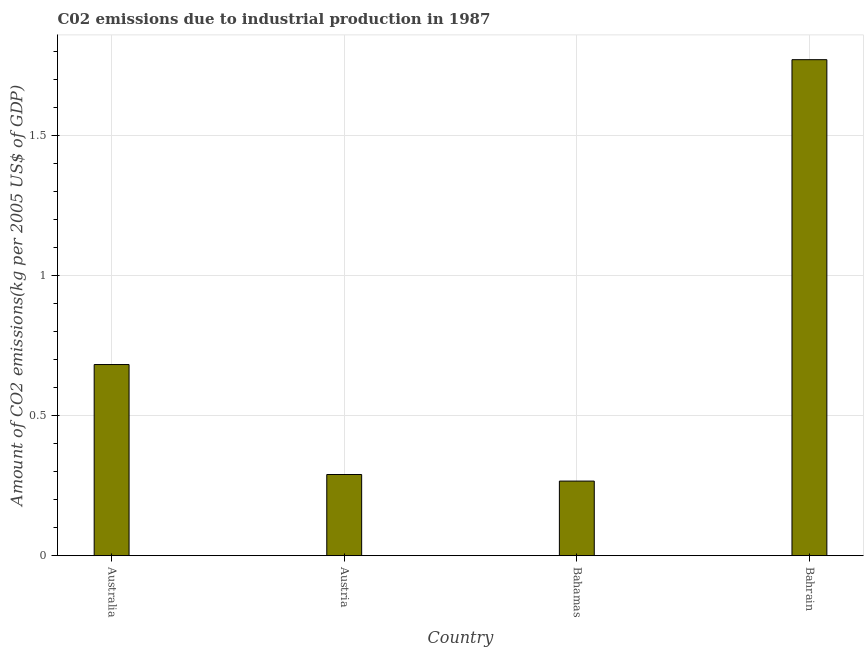Does the graph contain any zero values?
Make the answer very short. No. Does the graph contain grids?
Offer a very short reply. Yes. What is the title of the graph?
Provide a short and direct response. C02 emissions due to industrial production in 1987. What is the label or title of the X-axis?
Provide a succinct answer. Country. What is the label or title of the Y-axis?
Your answer should be very brief. Amount of CO2 emissions(kg per 2005 US$ of GDP). What is the amount of co2 emissions in Australia?
Your answer should be very brief. 0.68. Across all countries, what is the maximum amount of co2 emissions?
Provide a short and direct response. 1.77. Across all countries, what is the minimum amount of co2 emissions?
Offer a very short reply. 0.27. In which country was the amount of co2 emissions maximum?
Keep it short and to the point. Bahrain. In which country was the amount of co2 emissions minimum?
Provide a succinct answer. Bahamas. What is the sum of the amount of co2 emissions?
Keep it short and to the point. 3.01. What is the difference between the amount of co2 emissions in Austria and Bahamas?
Offer a terse response. 0.02. What is the average amount of co2 emissions per country?
Give a very brief answer. 0.75. What is the median amount of co2 emissions?
Give a very brief answer. 0.49. What is the ratio of the amount of co2 emissions in Australia to that in Austria?
Ensure brevity in your answer.  2.35. Is the amount of co2 emissions in Australia less than that in Austria?
Offer a very short reply. No. Is the difference between the amount of co2 emissions in Austria and Bahamas greater than the difference between any two countries?
Offer a terse response. No. What is the difference between the highest and the second highest amount of co2 emissions?
Provide a short and direct response. 1.09. What is the difference between the highest and the lowest amount of co2 emissions?
Offer a terse response. 1.5. How many bars are there?
Your response must be concise. 4. Are all the bars in the graph horizontal?
Offer a terse response. No. How many countries are there in the graph?
Your response must be concise. 4. What is the difference between two consecutive major ticks on the Y-axis?
Offer a terse response. 0.5. Are the values on the major ticks of Y-axis written in scientific E-notation?
Ensure brevity in your answer.  No. What is the Amount of CO2 emissions(kg per 2005 US$ of GDP) in Australia?
Offer a terse response. 0.68. What is the Amount of CO2 emissions(kg per 2005 US$ of GDP) of Austria?
Provide a succinct answer. 0.29. What is the Amount of CO2 emissions(kg per 2005 US$ of GDP) in Bahamas?
Offer a terse response. 0.27. What is the Amount of CO2 emissions(kg per 2005 US$ of GDP) in Bahrain?
Ensure brevity in your answer.  1.77. What is the difference between the Amount of CO2 emissions(kg per 2005 US$ of GDP) in Australia and Austria?
Provide a succinct answer. 0.39. What is the difference between the Amount of CO2 emissions(kg per 2005 US$ of GDP) in Australia and Bahamas?
Offer a terse response. 0.42. What is the difference between the Amount of CO2 emissions(kg per 2005 US$ of GDP) in Australia and Bahrain?
Give a very brief answer. -1.09. What is the difference between the Amount of CO2 emissions(kg per 2005 US$ of GDP) in Austria and Bahamas?
Offer a very short reply. 0.02. What is the difference between the Amount of CO2 emissions(kg per 2005 US$ of GDP) in Austria and Bahrain?
Ensure brevity in your answer.  -1.48. What is the difference between the Amount of CO2 emissions(kg per 2005 US$ of GDP) in Bahamas and Bahrain?
Offer a very short reply. -1.5. What is the ratio of the Amount of CO2 emissions(kg per 2005 US$ of GDP) in Australia to that in Austria?
Offer a terse response. 2.35. What is the ratio of the Amount of CO2 emissions(kg per 2005 US$ of GDP) in Australia to that in Bahamas?
Your response must be concise. 2.56. What is the ratio of the Amount of CO2 emissions(kg per 2005 US$ of GDP) in Australia to that in Bahrain?
Offer a terse response. 0.39. What is the ratio of the Amount of CO2 emissions(kg per 2005 US$ of GDP) in Austria to that in Bahamas?
Make the answer very short. 1.09. What is the ratio of the Amount of CO2 emissions(kg per 2005 US$ of GDP) in Austria to that in Bahrain?
Provide a succinct answer. 0.16. What is the ratio of the Amount of CO2 emissions(kg per 2005 US$ of GDP) in Bahamas to that in Bahrain?
Make the answer very short. 0.15. 